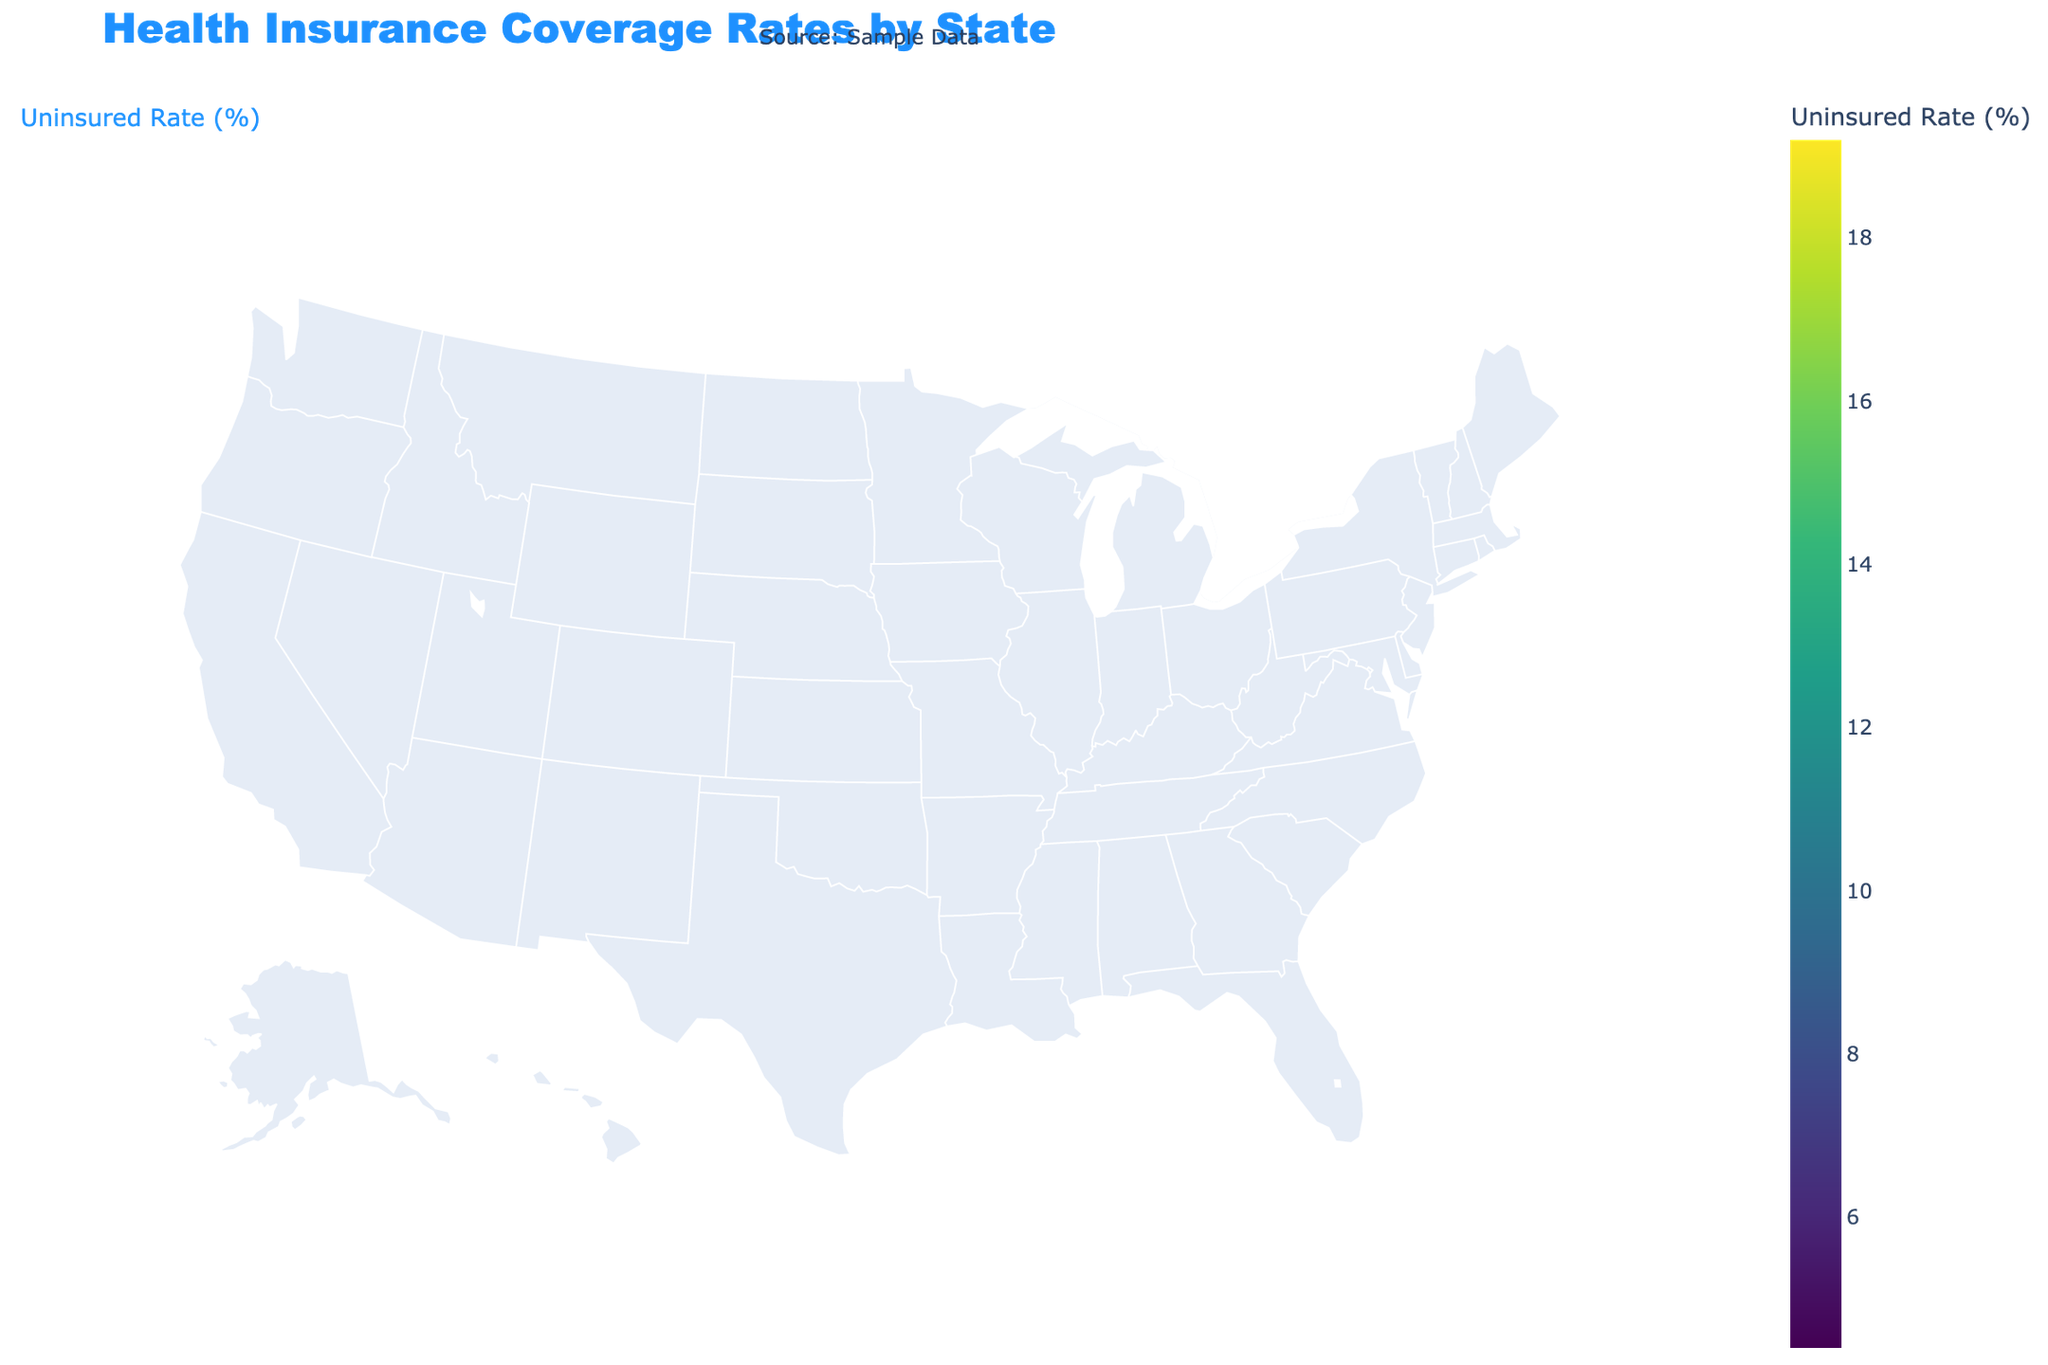What is the title of the figure? The title can be found at the top of the figure. It usually summarizes the main focus of the plot.
Answer: Health Insurance Coverage Rates by State Which state has the highest public insurance rate? To determine the state with the highest public insurance rate, look at the color-coded map. Check the tooltip information by hovering over each state and compare the public insurance rates.
Answer: New York What is the uninsured rate in Florida and how does it compare to California? Hover over Florida to see its uninsured rate and compare it to California by doing the same. Florida has an uninsured rate of 15.8%, and California is displayed as 9.0%.
Answer: Florida: 15.8%, higher than California Which state has the lowest uninsured rate and what is the exact value? Hover over each state to find the uninsured rates. Identify the state with the smallest value.
Answer: Massachusetts, 4.4% What is the average public insurance rate for the states shown in the plot? Sum the public insurance rates for all states and divide by the number of states. The rates are: 35.2, 28.5, 32.7, 40.1, 34.6, 37.8, 35.9, 30.4, 34.2, 38.5, 33.7, 29.8, 32.5, 35.6, 39.2, 37.1, 33.8, 32.4, 32.1, and 33.7. Total = 676.9 divided by 20 states.
Answer: Average: 33.85% Which state has the highest private insurance rate and what's the value? Hover over each state to see their private insurance rates and identify the highest one.
Answer: Maryland, 61.5% What is the difference in uninsured rates between Texas and Pennsylvania? Find the uninsured rates for Texas and Pennsylvania by hovering over them and subtract Pennsylvania's rate from Texas's rate. Texas has an uninsured rate of 19.2%, Pennsylvania has 7.1%.
Answer: Difference: 12.1% How do the public and private insurance rates in New York compare? Hover over New York to see both the public and private insurance rates. Compare the two values directly.
Answer: Public: 40.1%, Private: 52.3% Which state has a public insurance rate closest to 35%? Hover over the states and identify the one with a public insurance rate nearest to 35%. States with public insurance rates near 35% are California (35.2%), Ohio (35.9%), and Arizona (35.6%). California is closest.
Answer: California 